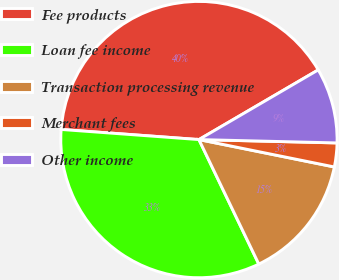Convert chart to OTSL. <chart><loc_0><loc_0><loc_500><loc_500><pie_chart><fcel>Fee products<fcel>Loan fee income<fcel>Transaction processing revenue<fcel>Merchant fees<fcel>Other income<nl><fcel>40.42%<fcel>33.3%<fcel>14.69%<fcel>2.79%<fcel>8.8%<nl></chart> 